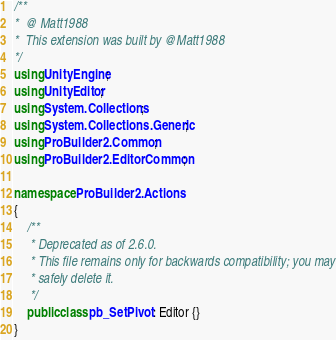Convert code to text. <code><loc_0><loc_0><loc_500><loc_500><_C#_>/**
*  @ Matt1988
*  This extension was built by @Matt1988
*/
using UnityEngine;
using UnityEditor;
using System.Collections;
using System.Collections.Generic;
using ProBuilder2.Common;
using ProBuilder2.EditorCommon;

namespace ProBuilder2.Actions
{
	/**
	 * Deprecated as of 2.6.0.
	 * This file remains only for backwards compatibility; you may
	 * safely delete it.
	 */
	public class pb_SetPivot : Editor {}
}
</code> 